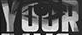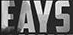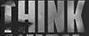Transcribe the words shown in these images in order, separated by a semicolon. YOUR; EAYS; THINK 